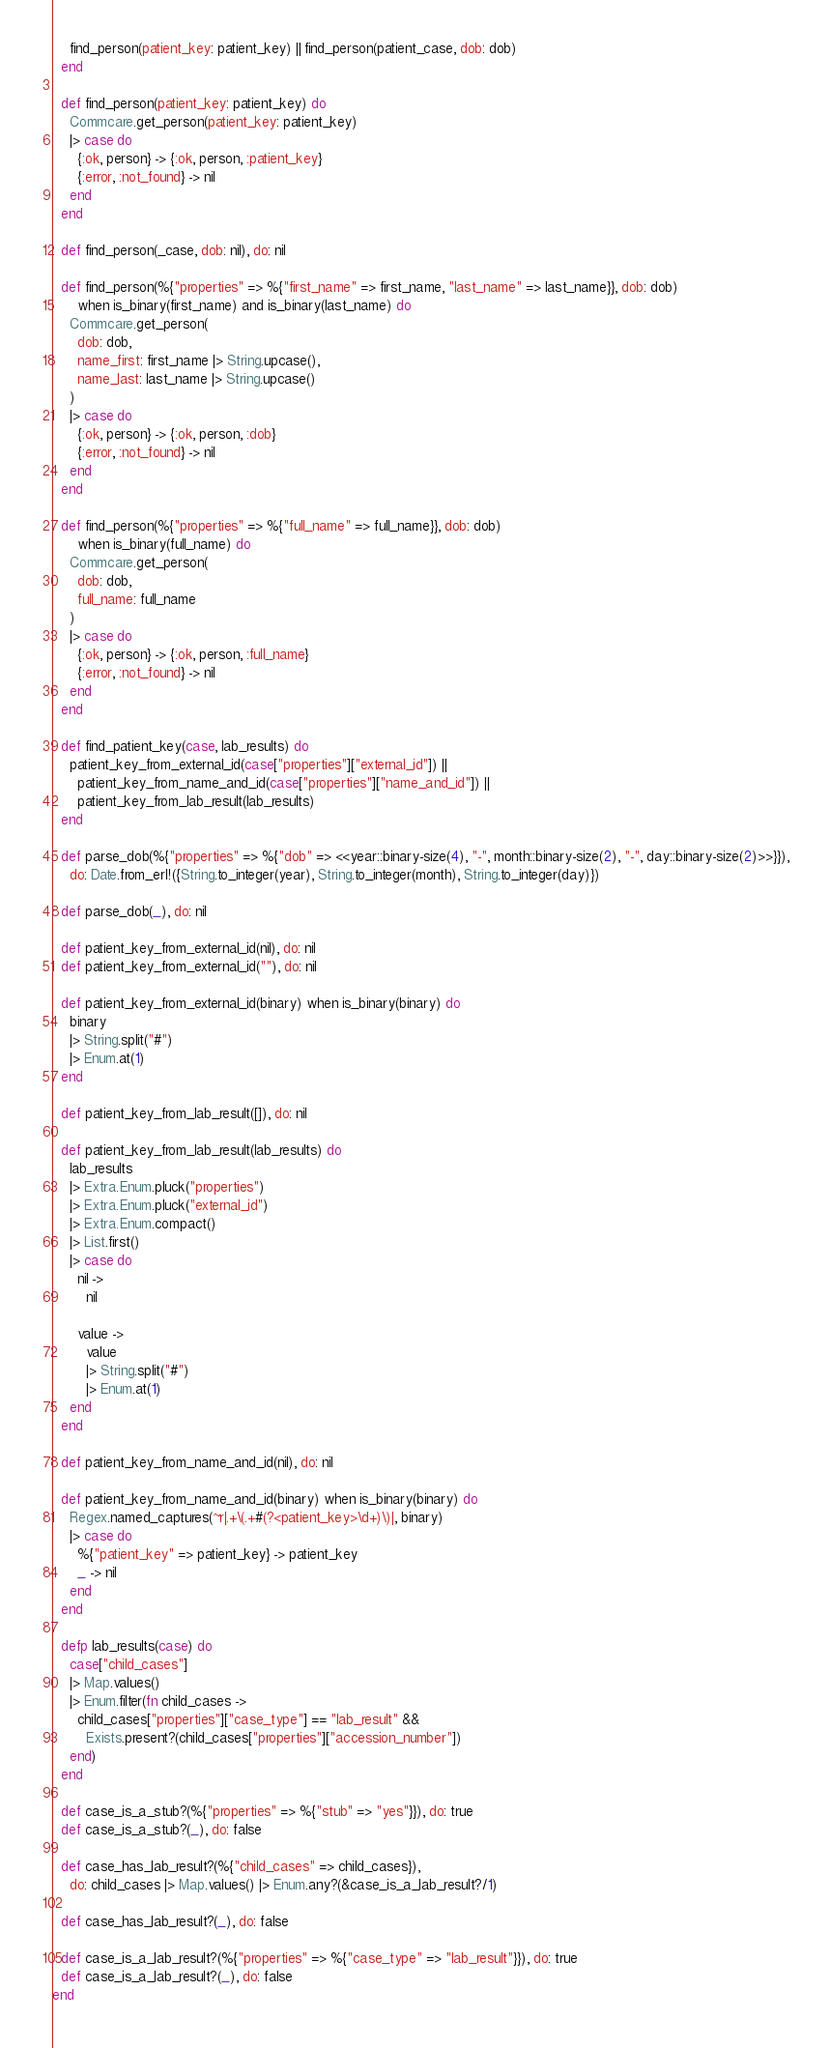<code> <loc_0><loc_0><loc_500><loc_500><_Elixir_>    find_person(patient_key: patient_key) || find_person(patient_case, dob: dob)
  end

  def find_person(patient_key: patient_key) do
    Commcare.get_person(patient_key: patient_key)
    |> case do
      {:ok, person} -> {:ok, person, :patient_key}
      {:error, :not_found} -> nil
    end
  end

  def find_person(_case, dob: nil), do: nil

  def find_person(%{"properties" => %{"first_name" => first_name, "last_name" => last_name}}, dob: dob)
      when is_binary(first_name) and is_binary(last_name) do
    Commcare.get_person(
      dob: dob,
      name_first: first_name |> String.upcase(),
      name_last: last_name |> String.upcase()
    )
    |> case do
      {:ok, person} -> {:ok, person, :dob}
      {:error, :not_found} -> nil
    end
  end

  def find_person(%{"properties" => %{"full_name" => full_name}}, dob: dob)
      when is_binary(full_name) do
    Commcare.get_person(
      dob: dob,
      full_name: full_name
    )
    |> case do
      {:ok, person} -> {:ok, person, :full_name}
      {:error, :not_found} -> nil
    end
  end

  def find_patient_key(case, lab_results) do
    patient_key_from_external_id(case["properties"]["external_id"]) ||
      patient_key_from_name_and_id(case["properties"]["name_and_id"]) ||
      patient_key_from_lab_result(lab_results)
  end

  def parse_dob(%{"properties" => %{"dob" => <<year::binary-size(4), "-", month::binary-size(2), "-", day::binary-size(2)>>}}),
    do: Date.from_erl!({String.to_integer(year), String.to_integer(month), String.to_integer(day)})

  def parse_dob(_), do: nil

  def patient_key_from_external_id(nil), do: nil
  def patient_key_from_external_id(""), do: nil

  def patient_key_from_external_id(binary) when is_binary(binary) do
    binary
    |> String.split("#")
    |> Enum.at(1)
  end

  def patient_key_from_lab_result([]), do: nil

  def patient_key_from_lab_result(lab_results) do
    lab_results
    |> Extra.Enum.pluck("properties")
    |> Extra.Enum.pluck("external_id")
    |> Extra.Enum.compact()
    |> List.first()
    |> case do
      nil ->
        nil

      value ->
        value
        |> String.split("#")
        |> Enum.at(1)
    end
  end

  def patient_key_from_name_and_id(nil), do: nil

  def patient_key_from_name_and_id(binary) when is_binary(binary) do
    Regex.named_captures(~r|.+\(.+#(?<patient_key>\d+)\)|, binary)
    |> case do
      %{"patient_key" => patient_key} -> patient_key
      _ -> nil
    end
  end

  defp lab_results(case) do
    case["child_cases"]
    |> Map.values()
    |> Enum.filter(fn child_cases ->
      child_cases["properties"]["case_type"] == "lab_result" &&
        Exists.present?(child_cases["properties"]["accession_number"])
    end)
  end

  def case_is_a_stub?(%{"properties" => %{"stub" => "yes"}}), do: true
  def case_is_a_stub?(_), do: false

  def case_has_lab_result?(%{"child_cases" => child_cases}),
    do: child_cases |> Map.values() |> Enum.any?(&case_is_a_lab_result?/1)

  def case_has_lab_result?(_), do: false

  def case_is_a_lab_result?(%{"properties" => %{"case_type" => "lab_result"}}), do: true
  def case_is_a_lab_result?(_), do: false
end
</code> 